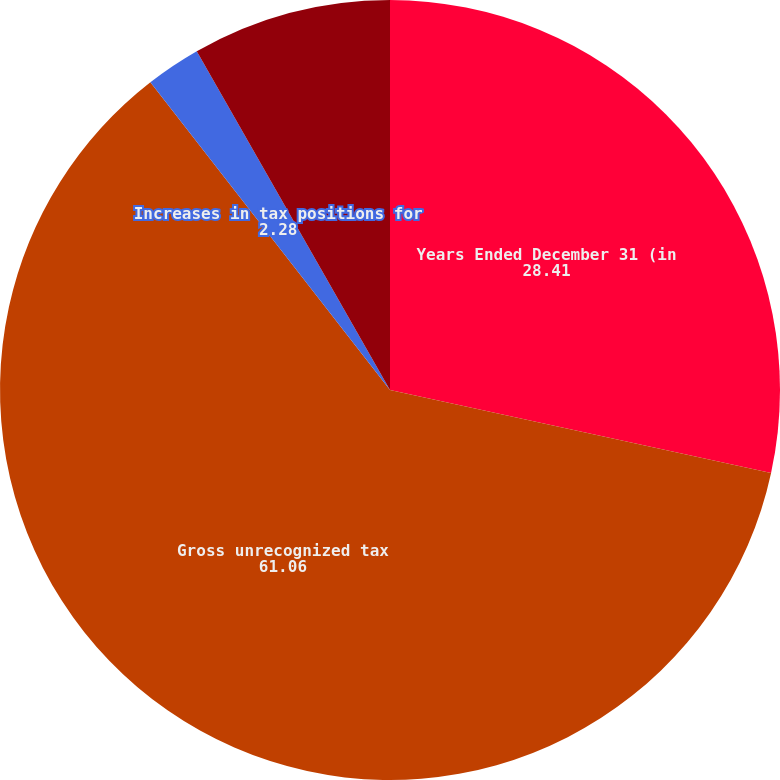Convert chart. <chart><loc_0><loc_0><loc_500><loc_500><pie_chart><fcel>Years Ended December 31 (in<fcel>Gross unrecognized tax<fcel>Increases in tax positions for<fcel>Decreases in tax positions for<nl><fcel>28.41%<fcel>61.06%<fcel>2.28%<fcel>8.25%<nl></chart> 